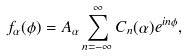<formula> <loc_0><loc_0><loc_500><loc_500>f _ { \alpha } ( \phi ) = A _ { \alpha } \sum _ { n = - \infty } ^ { \infty } C _ { n } ( \alpha ) e ^ { i n \phi } ,</formula> 